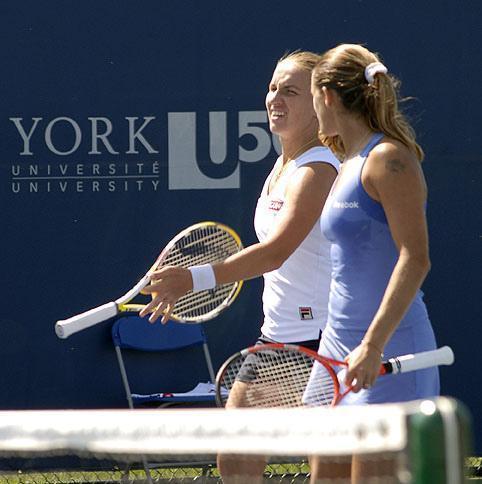How many people are in the picture?
Give a very brief answer. 2. How many folding chairs are there?
Give a very brief answer. 1. How many tennis rackets can you see?
Give a very brief answer. 2. How many people are in the photo?
Give a very brief answer. 2. 